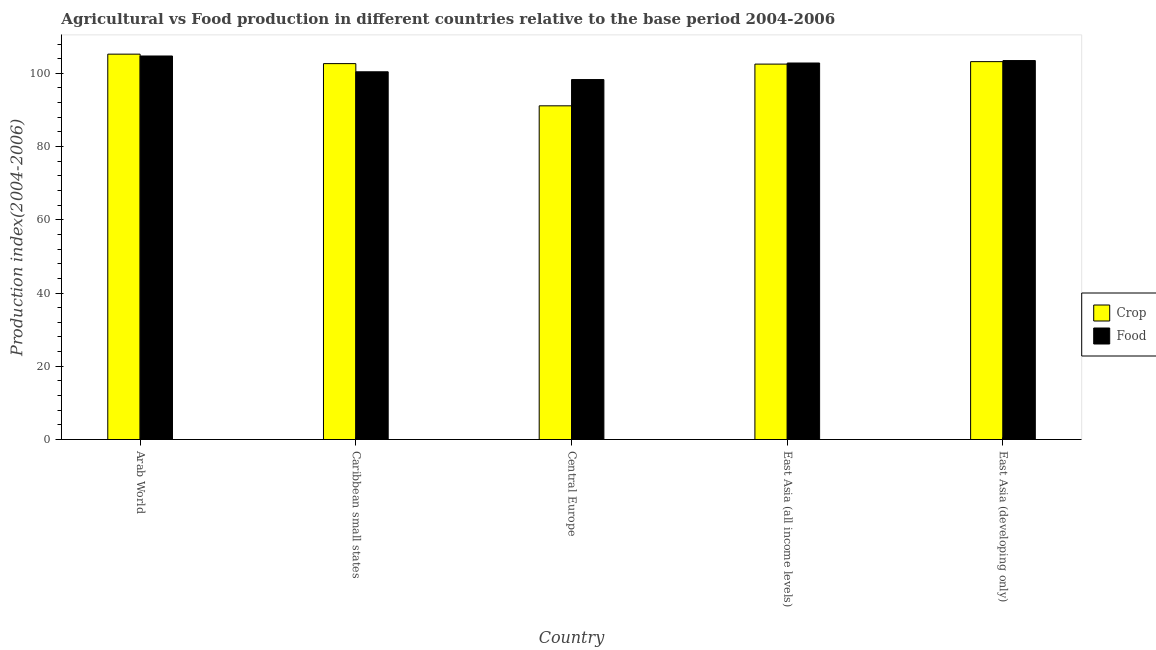How many different coloured bars are there?
Ensure brevity in your answer.  2. How many groups of bars are there?
Keep it short and to the point. 5. Are the number of bars per tick equal to the number of legend labels?
Your answer should be compact. Yes. Are the number of bars on each tick of the X-axis equal?
Give a very brief answer. Yes. How many bars are there on the 4th tick from the left?
Make the answer very short. 2. How many bars are there on the 1st tick from the right?
Provide a succinct answer. 2. What is the label of the 1st group of bars from the left?
Keep it short and to the point. Arab World. In how many cases, is the number of bars for a given country not equal to the number of legend labels?
Keep it short and to the point. 0. What is the food production index in East Asia (developing only)?
Give a very brief answer. 103.49. Across all countries, what is the maximum food production index?
Offer a very short reply. 104.73. Across all countries, what is the minimum crop production index?
Provide a short and direct response. 91.13. In which country was the food production index maximum?
Ensure brevity in your answer.  Arab World. In which country was the food production index minimum?
Your answer should be compact. Central Europe. What is the total crop production index in the graph?
Your answer should be compact. 504.73. What is the difference between the food production index in Caribbean small states and that in East Asia (developing only)?
Offer a very short reply. -3.07. What is the difference between the food production index in East Asia (all income levels) and the crop production index in Arab World?
Keep it short and to the point. -2.42. What is the average crop production index per country?
Provide a short and direct response. 100.95. What is the difference between the food production index and crop production index in East Asia (all income levels)?
Ensure brevity in your answer.  0.3. What is the ratio of the food production index in Caribbean small states to that in East Asia (all income levels)?
Keep it short and to the point. 0.98. Is the food production index in Arab World less than that in East Asia (all income levels)?
Offer a very short reply. No. What is the difference between the highest and the second highest food production index?
Your answer should be compact. 1.25. What is the difference between the highest and the lowest food production index?
Give a very brief answer. 6.43. In how many countries, is the crop production index greater than the average crop production index taken over all countries?
Make the answer very short. 4. What does the 1st bar from the left in East Asia (all income levels) represents?
Offer a terse response. Crop. What does the 1st bar from the right in Central Europe represents?
Keep it short and to the point. Food. How many countries are there in the graph?
Keep it short and to the point. 5. Does the graph contain any zero values?
Your answer should be compact. No. Does the graph contain grids?
Offer a terse response. No. Where does the legend appear in the graph?
Your answer should be compact. Center right. How many legend labels are there?
Offer a terse response. 2. What is the title of the graph?
Your response must be concise. Agricultural vs Food production in different countries relative to the base period 2004-2006. What is the label or title of the Y-axis?
Offer a very short reply. Production index(2004-2006). What is the Production index(2004-2006) in Crop in Arab World?
Provide a succinct answer. 105.24. What is the Production index(2004-2006) of Food in Arab World?
Your answer should be compact. 104.73. What is the Production index(2004-2006) in Crop in Caribbean small states?
Your answer should be very brief. 102.65. What is the Production index(2004-2006) of Food in Caribbean small states?
Provide a succinct answer. 100.42. What is the Production index(2004-2006) of Crop in Central Europe?
Ensure brevity in your answer.  91.13. What is the Production index(2004-2006) of Food in Central Europe?
Make the answer very short. 98.3. What is the Production index(2004-2006) in Crop in East Asia (all income levels)?
Give a very brief answer. 102.52. What is the Production index(2004-2006) of Food in East Asia (all income levels)?
Offer a very short reply. 102.82. What is the Production index(2004-2006) of Crop in East Asia (developing only)?
Offer a terse response. 103.19. What is the Production index(2004-2006) in Food in East Asia (developing only)?
Your response must be concise. 103.49. Across all countries, what is the maximum Production index(2004-2006) of Crop?
Your answer should be compact. 105.24. Across all countries, what is the maximum Production index(2004-2006) in Food?
Offer a very short reply. 104.73. Across all countries, what is the minimum Production index(2004-2006) of Crop?
Your answer should be very brief. 91.13. Across all countries, what is the minimum Production index(2004-2006) in Food?
Offer a very short reply. 98.3. What is the total Production index(2004-2006) of Crop in the graph?
Provide a short and direct response. 504.73. What is the total Production index(2004-2006) of Food in the graph?
Offer a very short reply. 509.75. What is the difference between the Production index(2004-2006) of Crop in Arab World and that in Caribbean small states?
Offer a terse response. 2.59. What is the difference between the Production index(2004-2006) in Food in Arab World and that in Caribbean small states?
Provide a short and direct response. 4.32. What is the difference between the Production index(2004-2006) in Crop in Arab World and that in Central Europe?
Offer a terse response. 14.11. What is the difference between the Production index(2004-2006) of Food in Arab World and that in Central Europe?
Provide a succinct answer. 6.43. What is the difference between the Production index(2004-2006) of Crop in Arab World and that in East Asia (all income levels)?
Ensure brevity in your answer.  2.72. What is the difference between the Production index(2004-2006) of Food in Arab World and that in East Asia (all income levels)?
Offer a terse response. 1.92. What is the difference between the Production index(2004-2006) of Crop in Arab World and that in East Asia (developing only)?
Provide a short and direct response. 2.04. What is the difference between the Production index(2004-2006) of Food in Arab World and that in East Asia (developing only)?
Offer a very short reply. 1.25. What is the difference between the Production index(2004-2006) of Crop in Caribbean small states and that in Central Europe?
Give a very brief answer. 11.52. What is the difference between the Production index(2004-2006) of Food in Caribbean small states and that in Central Europe?
Provide a short and direct response. 2.12. What is the difference between the Production index(2004-2006) of Crop in Caribbean small states and that in East Asia (all income levels)?
Your answer should be compact. 0.13. What is the difference between the Production index(2004-2006) of Food in Caribbean small states and that in East Asia (all income levels)?
Keep it short and to the point. -2.4. What is the difference between the Production index(2004-2006) of Crop in Caribbean small states and that in East Asia (developing only)?
Provide a short and direct response. -0.54. What is the difference between the Production index(2004-2006) of Food in Caribbean small states and that in East Asia (developing only)?
Keep it short and to the point. -3.07. What is the difference between the Production index(2004-2006) in Crop in Central Europe and that in East Asia (all income levels)?
Offer a very short reply. -11.39. What is the difference between the Production index(2004-2006) in Food in Central Europe and that in East Asia (all income levels)?
Keep it short and to the point. -4.52. What is the difference between the Production index(2004-2006) in Crop in Central Europe and that in East Asia (developing only)?
Provide a succinct answer. -12.07. What is the difference between the Production index(2004-2006) of Food in Central Europe and that in East Asia (developing only)?
Provide a succinct answer. -5.19. What is the difference between the Production index(2004-2006) of Crop in East Asia (all income levels) and that in East Asia (developing only)?
Provide a short and direct response. -0.68. What is the difference between the Production index(2004-2006) of Food in East Asia (all income levels) and that in East Asia (developing only)?
Ensure brevity in your answer.  -0.67. What is the difference between the Production index(2004-2006) in Crop in Arab World and the Production index(2004-2006) in Food in Caribbean small states?
Your answer should be compact. 4.82. What is the difference between the Production index(2004-2006) of Crop in Arab World and the Production index(2004-2006) of Food in Central Europe?
Your response must be concise. 6.94. What is the difference between the Production index(2004-2006) in Crop in Arab World and the Production index(2004-2006) in Food in East Asia (all income levels)?
Your answer should be compact. 2.42. What is the difference between the Production index(2004-2006) in Crop in Arab World and the Production index(2004-2006) in Food in East Asia (developing only)?
Your answer should be very brief. 1.75. What is the difference between the Production index(2004-2006) in Crop in Caribbean small states and the Production index(2004-2006) in Food in Central Europe?
Make the answer very short. 4.35. What is the difference between the Production index(2004-2006) of Crop in Caribbean small states and the Production index(2004-2006) of Food in East Asia (all income levels)?
Keep it short and to the point. -0.17. What is the difference between the Production index(2004-2006) of Crop in Caribbean small states and the Production index(2004-2006) of Food in East Asia (developing only)?
Ensure brevity in your answer.  -0.84. What is the difference between the Production index(2004-2006) of Crop in Central Europe and the Production index(2004-2006) of Food in East Asia (all income levels)?
Give a very brief answer. -11.69. What is the difference between the Production index(2004-2006) of Crop in Central Europe and the Production index(2004-2006) of Food in East Asia (developing only)?
Offer a terse response. -12.36. What is the difference between the Production index(2004-2006) in Crop in East Asia (all income levels) and the Production index(2004-2006) in Food in East Asia (developing only)?
Give a very brief answer. -0.97. What is the average Production index(2004-2006) of Crop per country?
Provide a succinct answer. 100.95. What is the average Production index(2004-2006) in Food per country?
Give a very brief answer. 101.95. What is the difference between the Production index(2004-2006) in Crop and Production index(2004-2006) in Food in Arab World?
Offer a terse response. 0.5. What is the difference between the Production index(2004-2006) in Crop and Production index(2004-2006) in Food in Caribbean small states?
Make the answer very short. 2.23. What is the difference between the Production index(2004-2006) in Crop and Production index(2004-2006) in Food in Central Europe?
Offer a terse response. -7.17. What is the difference between the Production index(2004-2006) of Crop and Production index(2004-2006) of Food in East Asia (all income levels)?
Offer a terse response. -0.3. What is the difference between the Production index(2004-2006) in Crop and Production index(2004-2006) in Food in East Asia (developing only)?
Your answer should be very brief. -0.29. What is the ratio of the Production index(2004-2006) in Crop in Arab World to that in Caribbean small states?
Offer a very short reply. 1.03. What is the ratio of the Production index(2004-2006) in Food in Arab World to that in Caribbean small states?
Offer a very short reply. 1.04. What is the ratio of the Production index(2004-2006) in Crop in Arab World to that in Central Europe?
Offer a very short reply. 1.15. What is the ratio of the Production index(2004-2006) in Food in Arab World to that in Central Europe?
Keep it short and to the point. 1.07. What is the ratio of the Production index(2004-2006) of Crop in Arab World to that in East Asia (all income levels)?
Offer a terse response. 1.03. What is the ratio of the Production index(2004-2006) of Food in Arab World to that in East Asia (all income levels)?
Ensure brevity in your answer.  1.02. What is the ratio of the Production index(2004-2006) of Crop in Arab World to that in East Asia (developing only)?
Ensure brevity in your answer.  1.02. What is the ratio of the Production index(2004-2006) in Crop in Caribbean small states to that in Central Europe?
Make the answer very short. 1.13. What is the ratio of the Production index(2004-2006) of Food in Caribbean small states to that in Central Europe?
Keep it short and to the point. 1.02. What is the ratio of the Production index(2004-2006) of Food in Caribbean small states to that in East Asia (all income levels)?
Offer a terse response. 0.98. What is the ratio of the Production index(2004-2006) of Food in Caribbean small states to that in East Asia (developing only)?
Keep it short and to the point. 0.97. What is the ratio of the Production index(2004-2006) of Crop in Central Europe to that in East Asia (all income levels)?
Provide a succinct answer. 0.89. What is the ratio of the Production index(2004-2006) in Food in Central Europe to that in East Asia (all income levels)?
Keep it short and to the point. 0.96. What is the ratio of the Production index(2004-2006) in Crop in Central Europe to that in East Asia (developing only)?
Offer a terse response. 0.88. What is the ratio of the Production index(2004-2006) of Food in Central Europe to that in East Asia (developing only)?
Make the answer very short. 0.95. What is the ratio of the Production index(2004-2006) in Crop in East Asia (all income levels) to that in East Asia (developing only)?
Give a very brief answer. 0.99. What is the ratio of the Production index(2004-2006) of Food in East Asia (all income levels) to that in East Asia (developing only)?
Offer a terse response. 0.99. What is the difference between the highest and the second highest Production index(2004-2006) of Crop?
Offer a terse response. 2.04. What is the difference between the highest and the second highest Production index(2004-2006) of Food?
Ensure brevity in your answer.  1.25. What is the difference between the highest and the lowest Production index(2004-2006) of Crop?
Your answer should be very brief. 14.11. What is the difference between the highest and the lowest Production index(2004-2006) in Food?
Ensure brevity in your answer.  6.43. 